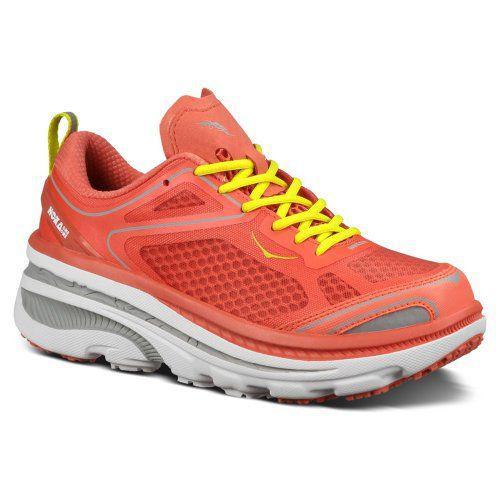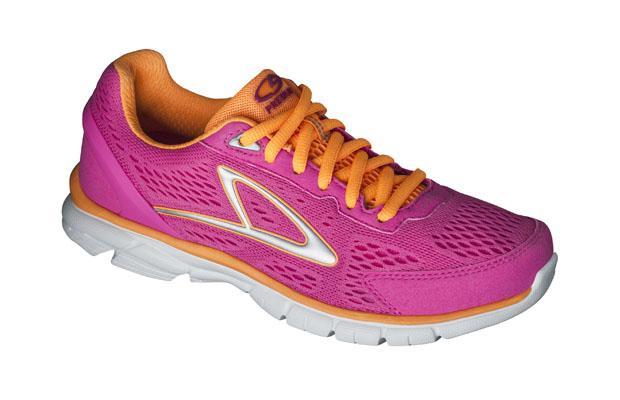The first image is the image on the left, the second image is the image on the right. Considering the images on both sides, is "The shoe in the image on the right has orange laces." valid? Answer yes or no. Yes. 